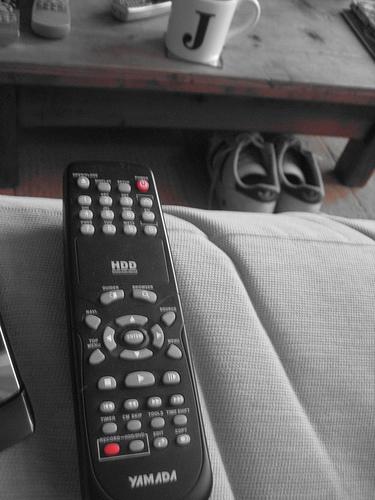Which remote has the least amount of colored buttons?
Be succinct. Center. What letter is on the coffee mug?
Short answer required. J. Is that a TV remote?
Quick response, please. Yes. What's under the table?
Concise answer only. Shoes. 